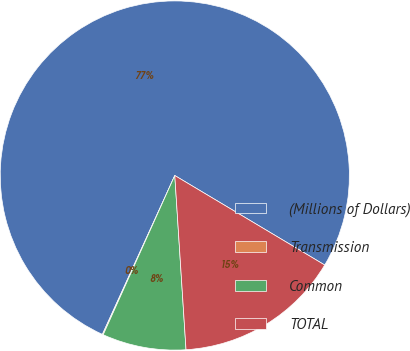<chart> <loc_0><loc_0><loc_500><loc_500><pie_chart><fcel>(Millions of Dollars)<fcel>Transmission<fcel>Common<fcel>TOTAL<nl><fcel>76.76%<fcel>0.08%<fcel>7.75%<fcel>15.41%<nl></chart> 